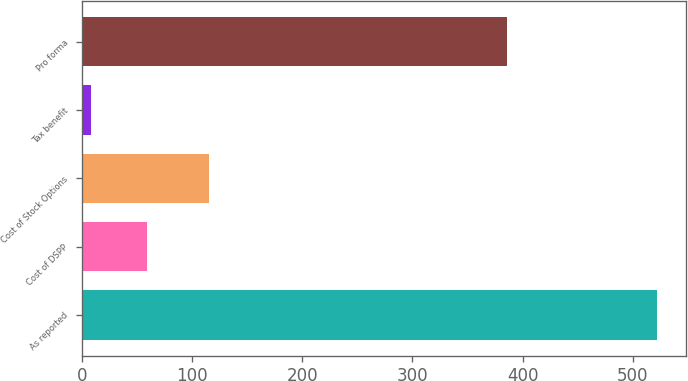<chart> <loc_0><loc_0><loc_500><loc_500><bar_chart><fcel>As reported<fcel>Cost of DSPP<fcel>Cost of Stock Options<fcel>Tax benefit<fcel>Pro forma<nl><fcel>522<fcel>59.4<fcel>115<fcel>8<fcel>386<nl></chart> 